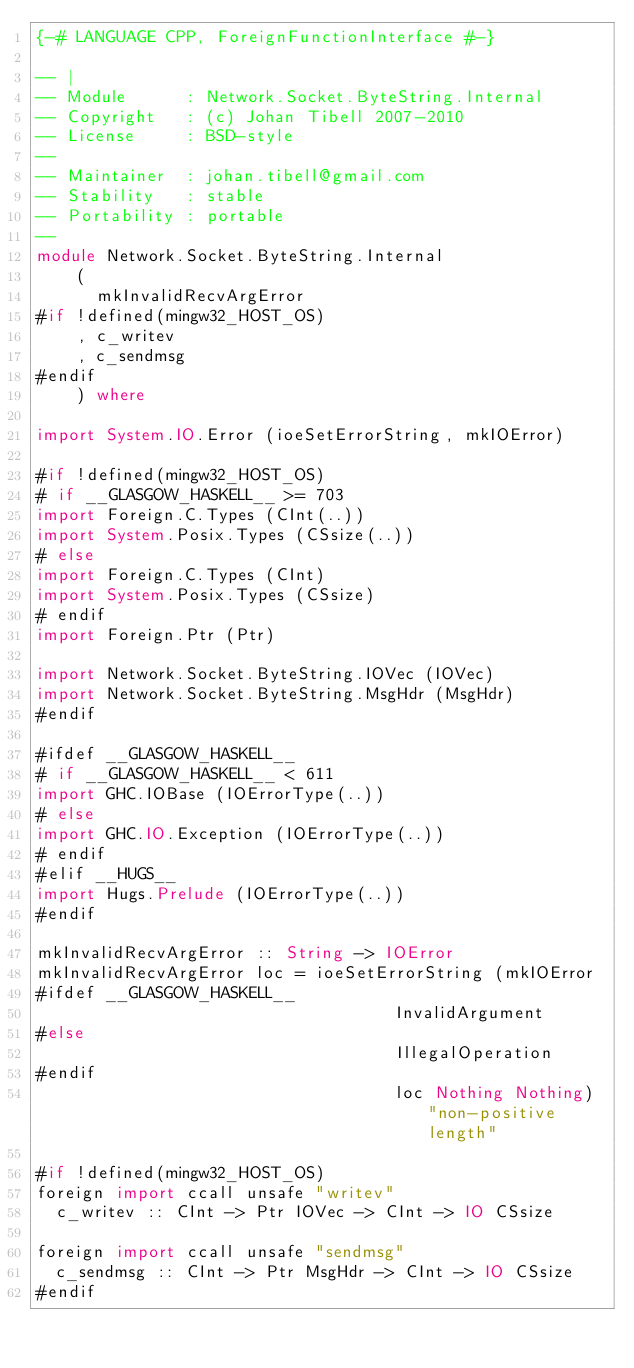<code> <loc_0><loc_0><loc_500><loc_500><_Haskell_>{-# LANGUAGE CPP, ForeignFunctionInterface #-}

-- |
-- Module      : Network.Socket.ByteString.Internal
-- Copyright   : (c) Johan Tibell 2007-2010
-- License     : BSD-style
--
-- Maintainer  : johan.tibell@gmail.com
-- Stability   : stable
-- Portability : portable
--
module Network.Socket.ByteString.Internal
    (
      mkInvalidRecvArgError
#if !defined(mingw32_HOST_OS)
    , c_writev
    , c_sendmsg
#endif
    ) where

import System.IO.Error (ioeSetErrorString, mkIOError)

#if !defined(mingw32_HOST_OS)
# if __GLASGOW_HASKELL__ >= 703
import Foreign.C.Types (CInt(..))
import System.Posix.Types (CSsize(..))
# else
import Foreign.C.Types (CInt)
import System.Posix.Types (CSsize)
# endif
import Foreign.Ptr (Ptr)

import Network.Socket.ByteString.IOVec (IOVec)
import Network.Socket.ByteString.MsgHdr (MsgHdr)
#endif

#ifdef __GLASGOW_HASKELL__
# if __GLASGOW_HASKELL__ < 611
import GHC.IOBase (IOErrorType(..))
# else
import GHC.IO.Exception (IOErrorType(..))
# endif
#elif __HUGS__
import Hugs.Prelude (IOErrorType(..))
#endif

mkInvalidRecvArgError :: String -> IOError
mkInvalidRecvArgError loc = ioeSetErrorString (mkIOError
#ifdef __GLASGOW_HASKELL__
                                    InvalidArgument
#else
                                    IllegalOperation
#endif
                                    loc Nothing Nothing) "non-positive length"

#if !defined(mingw32_HOST_OS)
foreign import ccall unsafe "writev"
  c_writev :: CInt -> Ptr IOVec -> CInt -> IO CSsize

foreign import ccall unsafe "sendmsg"
  c_sendmsg :: CInt -> Ptr MsgHdr -> CInt -> IO CSsize
#endif
</code> 